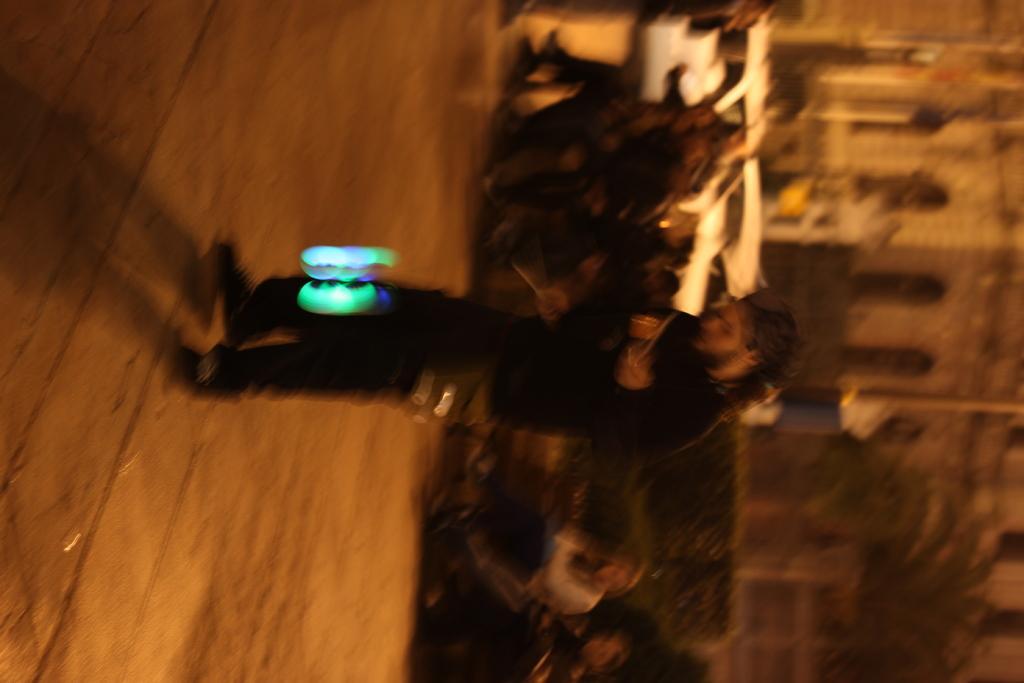In one or two sentences, can you explain what this image depicts? This is a rotated image. In this image there is a person standing on the road, in front of the person there something in colorful. The background is blurred. 